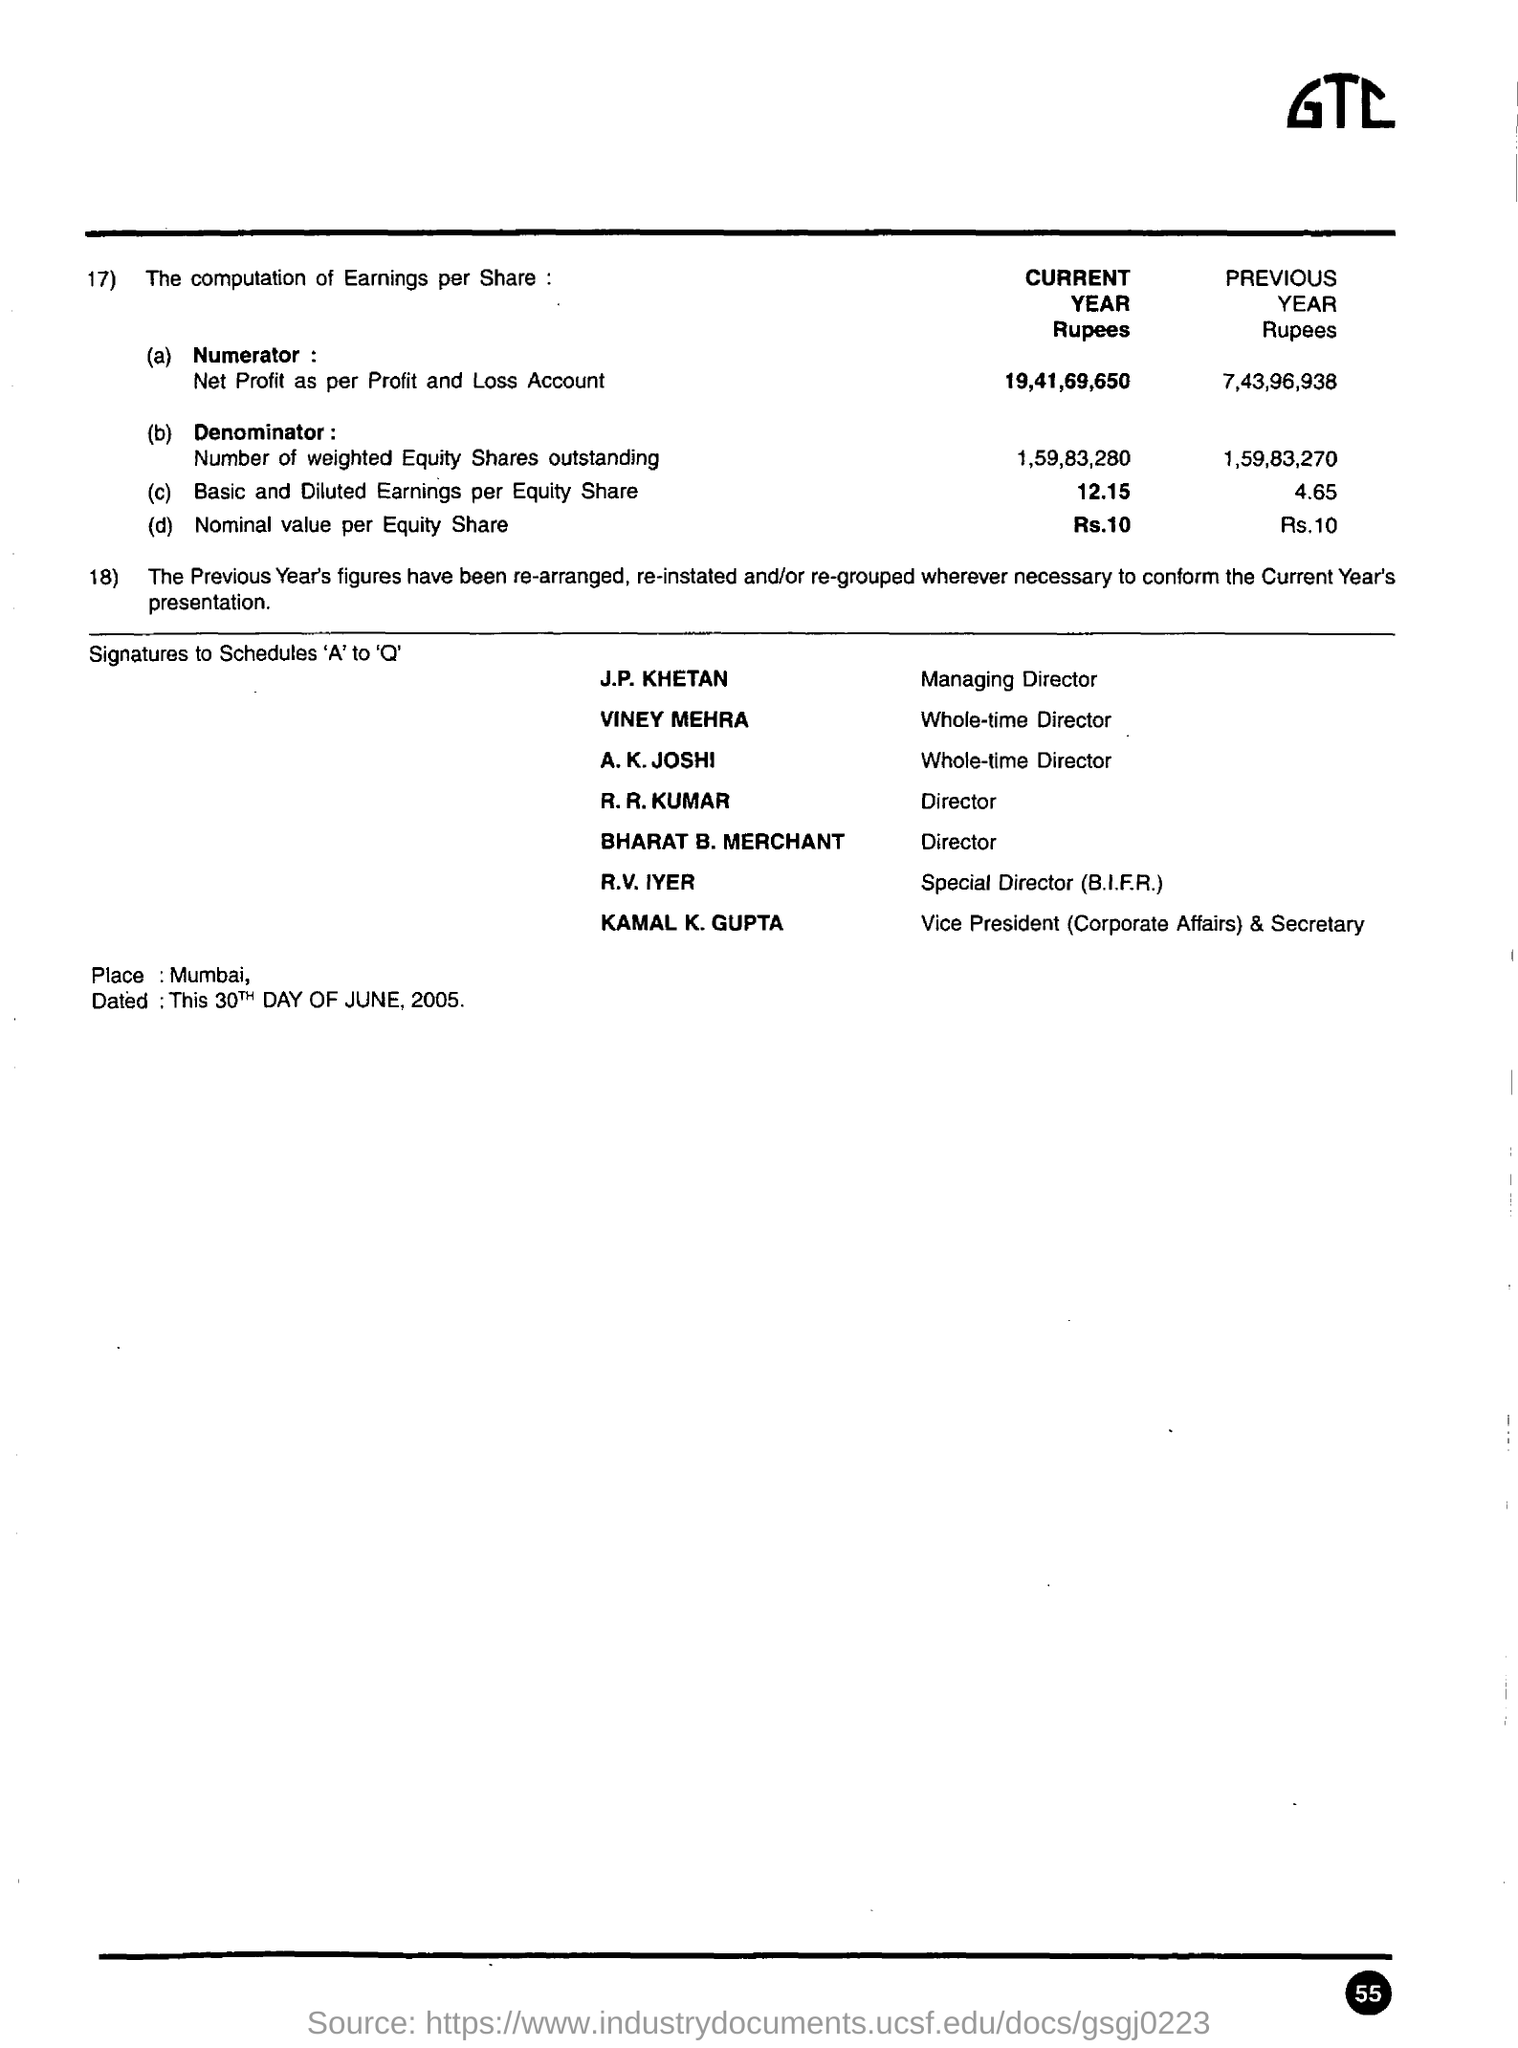Who is the managing director ?
Ensure brevity in your answer.  J.P. KHETAN. Who is the vice president (corporate affairs) & secretary
Provide a short and direct response. KAMAL K. GUPTA. What is the place mentioned ?
Provide a short and direct response. Mumbai. 